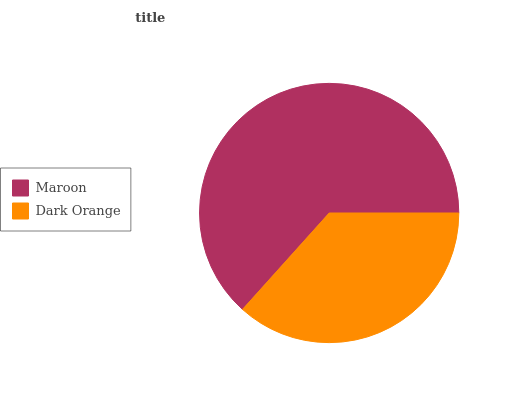Is Dark Orange the minimum?
Answer yes or no. Yes. Is Maroon the maximum?
Answer yes or no. Yes. Is Dark Orange the maximum?
Answer yes or no. No. Is Maroon greater than Dark Orange?
Answer yes or no. Yes. Is Dark Orange less than Maroon?
Answer yes or no. Yes. Is Dark Orange greater than Maroon?
Answer yes or no. No. Is Maroon less than Dark Orange?
Answer yes or no. No. Is Maroon the high median?
Answer yes or no. Yes. Is Dark Orange the low median?
Answer yes or no. Yes. Is Dark Orange the high median?
Answer yes or no. No. Is Maroon the low median?
Answer yes or no. No. 